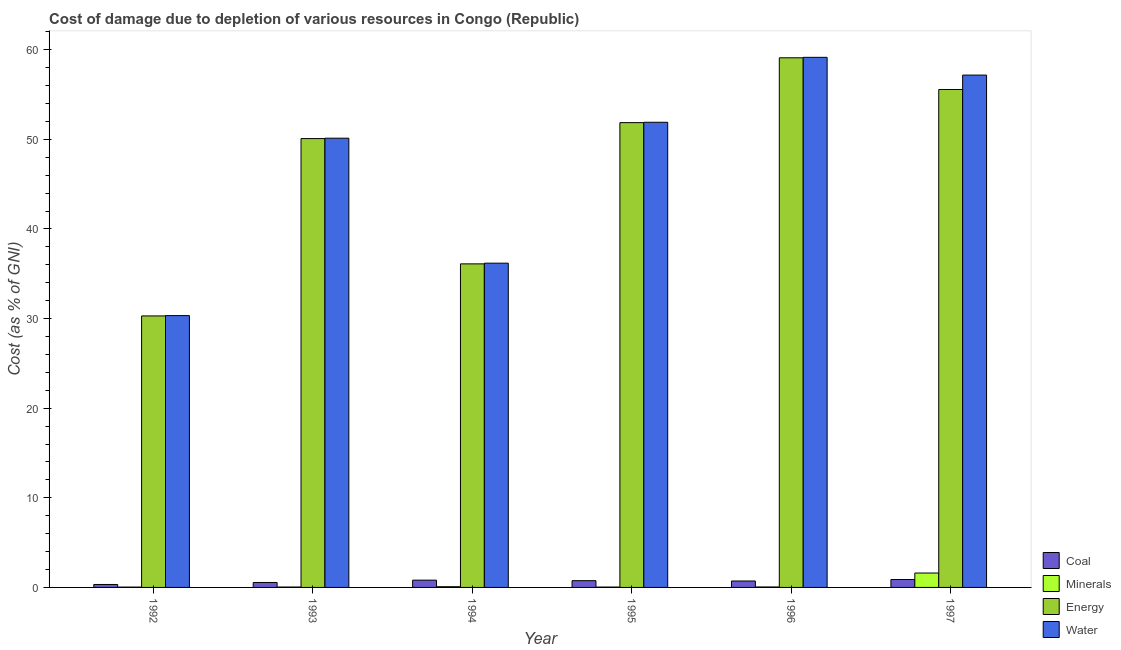How many groups of bars are there?
Provide a short and direct response. 6. How many bars are there on the 6th tick from the left?
Provide a short and direct response. 4. In how many cases, is the number of bars for a given year not equal to the number of legend labels?
Provide a succinct answer. 0. What is the cost of damage due to depletion of coal in 1995?
Keep it short and to the point. 0.75. Across all years, what is the maximum cost of damage due to depletion of minerals?
Provide a succinct answer. 1.61. Across all years, what is the minimum cost of damage due to depletion of energy?
Offer a terse response. 30.3. In which year was the cost of damage due to depletion of coal minimum?
Your answer should be compact. 1992. What is the total cost of damage due to depletion of energy in the graph?
Provide a succinct answer. 283.04. What is the difference between the cost of damage due to depletion of coal in 1992 and that in 1993?
Offer a very short reply. -0.22. What is the difference between the cost of damage due to depletion of water in 1992 and the cost of damage due to depletion of energy in 1993?
Keep it short and to the point. -19.8. What is the average cost of damage due to depletion of energy per year?
Provide a short and direct response. 47.17. What is the ratio of the cost of damage due to depletion of water in 1995 to that in 1996?
Ensure brevity in your answer.  0.88. Is the cost of damage due to depletion of coal in 1996 less than that in 1997?
Provide a succinct answer. Yes. What is the difference between the highest and the second highest cost of damage due to depletion of energy?
Ensure brevity in your answer.  3.54. What is the difference between the highest and the lowest cost of damage due to depletion of energy?
Your answer should be very brief. 28.81. In how many years, is the cost of damage due to depletion of water greater than the average cost of damage due to depletion of water taken over all years?
Your response must be concise. 4. What does the 3rd bar from the left in 1996 represents?
Your answer should be very brief. Energy. What does the 2nd bar from the right in 1994 represents?
Offer a very short reply. Energy. How many bars are there?
Offer a very short reply. 24. Are all the bars in the graph horizontal?
Make the answer very short. No. How many years are there in the graph?
Provide a succinct answer. 6. What is the difference between two consecutive major ticks on the Y-axis?
Ensure brevity in your answer.  10. Does the graph contain grids?
Your response must be concise. No. How are the legend labels stacked?
Your answer should be very brief. Vertical. What is the title of the graph?
Your answer should be compact. Cost of damage due to depletion of various resources in Congo (Republic) . What is the label or title of the X-axis?
Provide a short and direct response. Year. What is the label or title of the Y-axis?
Ensure brevity in your answer.  Cost (as % of GNI). What is the Cost (as % of GNI) in Coal in 1992?
Give a very brief answer. 0.33. What is the Cost (as % of GNI) of Minerals in 1992?
Offer a very short reply. 0.04. What is the Cost (as % of GNI) of Energy in 1992?
Give a very brief answer. 30.3. What is the Cost (as % of GNI) of Water in 1992?
Provide a succinct answer. 30.33. What is the Cost (as % of GNI) of Coal in 1993?
Ensure brevity in your answer.  0.55. What is the Cost (as % of GNI) of Minerals in 1993?
Offer a very short reply. 0.04. What is the Cost (as % of GNI) of Energy in 1993?
Your response must be concise. 50.09. What is the Cost (as % of GNI) in Water in 1993?
Provide a succinct answer. 50.13. What is the Cost (as % of GNI) of Coal in 1994?
Your answer should be compact. 0.81. What is the Cost (as % of GNI) of Minerals in 1994?
Provide a short and direct response. 0.08. What is the Cost (as % of GNI) of Energy in 1994?
Offer a very short reply. 36.11. What is the Cost (as % of GNI) of Water in 1994?
Provide a short and direct response. 36.19. What is the Cost (as % of GNI) of Coal in 1995?
Offer a very short reply. 0.75. What is the Cost (as % of GNI) of Minerals in 1995?
Your answer should be very brief. 0.04. What is the Cost (as % of GNI) in Energy in 1995?
Offer a very short reply. 51.87. What is the Cost (as % of GNI) of Water in 1995?
Give a very brief answer. 51.91. What is the Cost (as % of GNI) in Coal in 1996?
Provide a succinct answer. 0.72. What is the Cost (as % of GNI) in Minerals in 1996?
Keep it short and to the point. 0.05. What is the Cost (as % of GNI) of Energy in 1996?
Keep it short and to the point. 59.11. What is the Cost (as % of GNI) of Water in 1996?
Ensure brevity in your answer.  59.16. What is the Cost (as % of GNI) of Coal in 1997?
Keep it short and to the point. 0.88. What is the Cost (as % of GNI) in Minerals in 1997?
Keep it short and to the point. 1.61. What is the Cost (as % of GNI) in Energy in 1997?
Ensure brevity in your answer.  55.57. What is the Cost (as % of GNI) in Water in 1997?
Ensure brevity in your answer.  57.18. Across all years, what is the maximum Cost (as % of GNI) of Coal?
Offer a terse response. 0.88. Across all years, what is the maximum Cost (as % of GNI) of Minerals?
Your answer should be compact. 1.61. Across all years, what is the maximum Cost (as % of GNI) in Energy?
Offer a terse response. 59.11. Across all years, what is the maximum Cost (as % of GNI) in Water?
Provide a succinct answer. 59.16. Across all years, what is the minimum Cost (as % of GNI) of Coal?
Make the answer very short. 0.33. Across all years, what is the minimum Cost (as % of GNI) of Minerals?
Offer a terse response. 0.04. Across all years, what is the minimum Cost (as % of GNI) of Energy?
Provide a succinct answer. 30.3. Across all years, what is the minimum Cost (as % of GNI) of Water?
Give a very brief answer. 30.33. What is the total Cost (as % of GNI) of Coal in the graph?
Provide a succinct answer. 4.05. What is the total Cost (as % of GNI) of Minerals in the graph?
Make the answer very short. 1.86. What is the total Cost (as % of GNI) in Energy in the graph?
Keep it short and to the point. 283.04. What is the total Cost (as % of GNI) of Water in the graph?
Offer a terse response. 284.89. What is the difference between the Cost (as % of GNI) in Coal in 1992 and that in 1993?
Give a very brief answer. -0.22. What is the difference between the Cost (as % of GNI) of Minerals in 1992 and that in 1993?
Offer a very short reply. -0.01. What is the difference between the Cost (as % of GNI) of Energy in 1992 and that in 1993?
Your answer should be very brief. -19.79. What is the difference between the Cost (as % of GNI) in Water in 1992 and that in 1993?
Provide a short and direct response. -19.8. What is the difference between the Cost (as % of GNI) in Coal in 1992 and that in 1994?
Your response must be concise. -0.48. What is the difference between the Cost (as % of GNI) of Minerals in 1992 and that in 1994?
Keep it short and to the point. -0.04. What is the difference between the Cost (as % of GNI) in Energy in 1992 and that in 1994?
Make the answer very short. -5.81. What is the difference between the Cost (as % of GNI) of Water in 1992 and that in 1994?
Give a very brief answer. -5.85. What is the difference between the Cost (as % of GNI) in Coal in 1992 and that in 1995?
Ensure brevity in your answer.  -0.42. What is the difference between the Cost (as % of GNI) of Minerals in 1992 and that in 1995?
Keep it short and to the point. -0. What is the difference between the Cost (as % of GNI) of Energy in 1992 and that in 1995?
Your answer should be very brief. -21.57. What is the difference between the Cost (as % of GNI) in Water in 1992 and that in 1995?
Make the answer very short. -21.57. What is the difference between the Cost (as % of GNI) in Coal in 1992 and that in 1996?
Your response must be concise. -0.39. What is the difference between the Cost (as % of GNI) of Minerals in 1992 and that in 1996?
Provide a succinct answer. -0.01. What is the difference between the Cost (as % of GNI) of Energy in 1992 and that in 1996?
Your answer should be very brief. -28.81. What is the difference between the Cost (as % of GNI) in Water in 1992 and that in 1996?
Provide a short and direct response. -28.82. What is the difference between the Cost (as % of GNI) of Coal in 1992 and that in 1997?
Keep it short and to the point. -0.55. What is the difference between the Cost (as % of GNI) in Minerals in 1992 and that in 1997?
Provide a short and direct response. -1.57. What is the difference between the Cost (as % of GNI) in Energy in 1992 and that in 1997?
Provide a short and direct response. -25.27. What is the difference between the Cost (as % of GNI) of Water in 1992 and that in 1997?
Your answer should be compact. -26.84. What is the difference between the Cost (as % of GNI) of Coal in 1993 and that in 1994?
Make the answer very short. -0.26. What is the difference between the Cost (as % of GNI) in Minerals in 1993 and that in 1994?
Provide a succinct answer. -0.04. What is the difference between the Cost (as % of GNI) of Energy in 1993 and that in 1994?
Provide a short and direct response. 13.98. What is the difference between the Cost (as % of GNI) of Water in 1993 and that in 1994?
Your answer should be compact. 13.94. What is the difference between the Cost (as % of GNI) in Coal in 1993 and that in 1995?
Ensure brevity in your answer.  -0.2. What is the difference between the Cost (as % of GNI) in Minerals in 1993 and that in 1995?
Your answer should be very brief. 0. What is the difference between the Cost (as % of GNI) in Energy in 1993 and that in 1995?
Provide a short and direct response. -1.78. What is the difference between the Cost (as % of GNI) in Water in 1993 and that in 1995?
Your answer should be compact. -1.78. What is the difference between the Cost (as % of GNI) of Coal in 1993 and that in 1996?
Ensure brevity in your answer.  -0.17. What is the difference between the Cost (as % of GNI) in Minerals in 1993 and that in 1996?
Provide a succinct answer. -0.01. What is the difference between the Cost (as % of GNI) of Energy in 1993 and that in 1996?
Provide a succinct answer. -9.02. What is the difference between the Cost (as % of GNI) in Water in 1993 and that in 1996?
Your answer should be very brief. -9.03. What is the difference between the Cost (as % of GNI) in Coal in 1993 and that in 1997?
Provide a succinct answer. -0.33. What is the difference between the Cost (as % of GNI) in Minerals in 1993 and that in 1997?
Offer a very short reply. -1.56. What is the difference between the Cost (as % of GNI) in Energy in 1993 and that in 1997?
Provide a short and direct response. -5.48. What is the difference between the Cost (as % of GNI) of Water in 1993 and that in 1997?
Make the answer very short. -7.04. What is the difference between the Cost (as % of GNI) in Coal in 1994 and that in 1995?
Provide a short and direct response. 0.06. What is the difference between the Cost (as % of GNI) of Minerals in 1994 and that in 1995?
Ensure brevity in your answer.  0.04. What is the difference between the Cost (as % of GNI) in Energy in 1994 and that in 1995?
Provide a succinct answer. -15.76. What is the difference between the Cost (as % of GNI) of Water in 1994 and that in 1995?
Keep it short and to the point. -15.72. What is the difference between the Cost (as % of GNI) of Coal in 1994 and that in 1996?
Ensure brevity in your answer.  0.09. What is the difference between the Cost (as % of GNI) in Minerals in 1994 and that in 1996?
Offer a very short reply. 0.03. What is the difference between the Cost (as % of GNI) in Energy in 1994 and that in 1996?
Offer a very short reply. -23. What is the difference between the Cost (as % of GNI) in Water in 1994 and that in 1996?
Offer a terse response. -22.97. What is the difference between the Cost (as % of GNI) in Coal in 1994 and that in 1997?
Keep it short and to the point. -0.07. What is the difference between the Cost (as % of GNI) of Minerals in 1994 and that in 1997?
Give a very brief answer. -1.53. What is the difference between the Cost (as % of GNI) in Energy in 1994 and that in 1997?
Offer a terse response. -19.46. What is the difference between the Cost (as % of GNI) of Water in 1994 and that in 1997?
Your answer should be very brief. -20.99. What is the difference between the Cost (as % of GNI) of Coal in 1995 and that in 1996?
Your response must be concise. 0.04. What is the difference between the Cost (as % of GNI) in Minerals in 1995 and that in 1996?
Your answer should be compact. -0.01. What is the difference between the Cost (as % of GNI) of Energy in 1995 and that in 1996?
Give a very brief answer. -7.24. What is the difference between the Cost (as % of GNI) of Water in 1995 and that in 1996?
Give a very brief answer. -7.25. What is the difference between the Cost (as % of GNI) of Coal in 1995 and that in 1997?
Provide a succinct answer. -0.13. What is the difference between the Cost (as % of GNI) of Minerals in 1995 and that in 1997?
Give a very brief answer. -1.57. What is the difference between the Cost (as % of GNI) in Energy in 1995 and that in 1997?
Keep it short and to the point. -3.7. What is the difference between the Cost (as % of GNI) of Water in 1995 and that in 1997?
Offer a terse response. -5.27. What is the difference between the Cost (as % of GNI) in Coal in 1996 and that in 1997?
Your answer should be compact. -0.17. What is the difference between the Cost (as % of GNI) of Minerals in 1996 and that in 1997?
Offer a very short reply. -1.56. What is the difference between the Cost (as % of GNI) in Energy in 1996 and that in 1997?
Provide a short and direct response. 3.54. What is the difference between the Cost (as % of GNI) of Water in 1996 and that in 1997?
Your answer should be compact. 1.98. What is the difference between the Cost (as % of GNI) of Coal in 1992 and the Cost (as % of GNI) of Minerals in 1993?
Keep it short and to the point. 0.29. What is the difference between the Cost (as % of GNI) of Coal in 1992 and the Cost (as % of GNI) of Energy in 1993?
Give a very brief answer. -49.76. What is the difference between the Cost (as % of GNI) in Coal in 1992 and the Cost (as % of GNI) in Water in 1993?
Your answer should be very brief. -49.8. What is the difference between the Cost (as % of GNI) of Minerals in 1992 and the Cost (as % of GNI) of Energy in 1993?
Make the answer very short. -50.05. What is the difference between the Cost (as % of GNI) in Minerals in 1992 and the Cost (as % of GNI) in Water in 1993?
Keep it short and to the point. -50.1. What is the difference between the Cost (as % of GNI) in Energy in 1992 and the Cost (as % of GNI) in Water in 1993?
Give a very brief answer. -19.83. What is the difference between the Cost (as % of GNI) in Coal in 1992 and the Cost (as % of GNI) in Minerals in 1994?
Make the answer very short. 0.25. What is the difference between the Cost (as % of GNI) of Coal in 1992 and the Cost (as % of GNI) of Energy in 1994?
Provide a short and direct response. -35.78. What is the difference between the Cost (as % of GNI) of Coal in 1992 and the Cost (as % of GNI) of Water in 1994?
Provide a succinct answer. -35.86. What is the difference between the Cost (as % of GNI) in Minerals in 1992 and the Cost (as % of GNI) in Energy in 1994?
Keep it short and to the point. -36.07. What is the difference between the Cost (as % of GNI) in Minerals in 1992 and the Cost (as % of GNI) in Water in 1994?
Provide a succinct answer. -36.15. What is the difference between the Cost (as % of GNI) in Energy in 1992 and the Cost (as % of GNI) in Water in 1994?
Offer a terse response. -5.89. What is the difference between the Cost (as % of GNI) of Coal in 1992 and the Cost (as % of GNI) of Minerals in 1995?
Ensure brevity in your answer.  0.29. What is the difference between the Cost (as % of GNI) in Coal in 1992 and the Cost (as % of GNI) in Energy in 1995?
Offer a very short reply. -51.54. What is the difference between the Cost (as % of GNI) in Coal in 1992 and the Cost (as % of GNI) in Water in 1995?
Your response must be concise. -51.58. What is the difference between the Cost (as % of GNI) in Minerals in 1992 and the Cost (as % of GNI) in Energy in 1995?
Keep it short and to the point. -51.83. What is the difference between the Cost (as % of GNI) in Minerals in 1992 and the Cost (as % of GNI) in Water in 1995?
Make the answer very short. -51.87. What is the difference between the Cost (as % of GNI) in Energy in 1992 and the Cost (as % of GNI) in Water in 1995?
Ensure brevity in your answer.  -21.61. What is the difference between the Cost (as % of GNI) in Coal in 1992 and the Cost (as % of GNI) in Minerals in 1996?
Keep it short and to the point. 0.28. What is the difference between the Cost (as % of GNI) in Coal in 1992 and the Cost (as % of GNI) in Energy in 1996?
Your answer should be compact. -58.78. What is the difference between the Cost (as % of GNI) in Coal in 1992 and the Cost (as % of GNI) in Water in 1996?
Keep it short and to the point. -58.83. What is the difference between the Cost (as % of GNI) in Minerals in 1992 and the Cost (as % of GNI) in Energy in 1996?
Your answer should be compact. -59.07. What is the difference between the Cost (as % of GNI) in Minerals in 1992 and the Cost (as % of GNI) in Water in 1996?
Your answer should be compact. -59.12. What is the difference between the Cost (as % of GNI) of Energy in 1992 and the Cost (as % of GNI) of Water in 1996?
Make the answer very short. -28.86. What is the difference between the Cost (as % of GNI) of Coal in 1992 and the Cost (as % of GNI) of Minerals in 1997?
Offer a terse response. -1.28. What is the difference between the Cost (as % of GNI) of Coal in 1992 and the Cost (as % of GNI) of Energy in 1997?
Your answer should be compact. -55.24. What is the difference between the Cost (as % of GNI) of Coal in 1992 and the Cost (as % of GNI) of Water in 1997?
Your answer should be compact. -56.85. What is the difference between the Cost (as % of GNI) in Minerals in 1992 and the Cost (as % of GNI) in Energy in 1997?
Offer a terse response. -55.53. What is the difference between the Cost (as % of GNI) in Minerals in 1992 and the Cost (as % of GNI) in Water in 1997?
Make the answer very short. -57.14. What is the difference between the Cost (as % of GNI) of Energy in 1992 and the Cost (as % of GNI) of Water in 1997?
Keep it short and to the point. -26.88. What is the difference between the Cost (as % of GNI) of Coal in 1993 and the Cost (as % of GNI) of Minerals in 1994?
Offer a terse response. 0.47. What is the difference between the Cost (as % of GNI) of Coal in 1993 and the Cost (as % of GNI) of Energy in 1994?
Provide a succinct answer. -35.55. What is the difference between the Cost (as % of GNI) in Coal in 1993 and the Cost (as % of GNI) in Water in 1994?
Ensure brevity in your answer.  -35.63. What is the difference between the Cost (as % of GNI) of Minerals in 1993 and the Cost (as % of GNI) of Energy in 1994?
Give a very brief answer. -36.06. What is the difference between the Cost (as % of GNI) of Minerals in 1993 and the Cost (as % of GNI) of Water in 1994?
Your answer should be compact. -36.14. What is the difference between the Cost (as % of GNI) of Energy in 1993 and the Cost (as % of GNI) of Water in 1994?
Your answer should be very brief. 13.9. What is the difference between the Cost (as % of GNI) in Coal in 1993 and the Cost (as % of GNI) in Minerals in 1995?
Provide a succinct answer. 0.51. What is the difference between the Cost (as % of GNI) of Coal in 1993 and the Cost (as % of GNI) of Energy in 1995?
Your answer should be very brief. -51.32. What is the difference between the Cost (as % of GNI) of Coal in 1993 and the Cost (as % of GNI) of Water in 1995?
Give a very brief answer. -51.36. What is the difference between the Cost (as % of GNI) in Minerals in 1993 and the Cost (as % of GNI) in Energy in 1995?
Make the answer very short. -51.83. What is the difference between the Cost (as % of GNI) of Minerals in 1993 and the Cost (as % of GNI) of Water in 1995?
Make the answer very short. -51.87. What is the difference between the Cost (as % of GNI) of Energy in 1993 and the Cost (as % of GNI) of Water in 1995?
Offer a very short reply. -1.82. What is the difference between the Cost (as % of GNI) in Coal in 1993 and the Cost (as % of GNI) in Minerals in 1996?
Ensure brevity in your answer.  0.5. What is the difference between the Cost (as % of GNI) of Coal in 1993 and the Cost (as % of GNI) of Energy in 1996?
Provide a succinct answer. -58.55. What is the difference between the Cost (as % of GNI) in Coal in 1993 and the Cost (as % of GNI) in Water in 1996?
Keep it short and to the point. -58.6. What is the difference between the Cost (as % of GNI) in Minerals in 1993 and the Cost (as % of GNI) in Energy in 1996?
Offer a very short reply. -59.06. What is the difference between the Cost (as % of GNI) of Minerals in 1993 and the Cost (as % of GNI) of Water in 1996?
Offer a very short reply. -59.11. What is the difference between the Cost (as % of GNI) in Energy in 1993 and the Cost (as % of GNI) in Water in 1996?
Provide a short and direct response. -9.07. What is the difference between the Cost (as % of GNI) in Coal in 1993 and the Cost (as % of GNI) in Minerals in 1997?
Give a very brief answer. -1.05. What is the difference between the Cost (as % of GNI) of Coal in 1993 and the Cost (as % of GNI) of Energy in 1997?
Make the answer very short. -55.01. What is the difference between the Cost (as % of GNI) in Coal in 1993 and the Cost (as % of GNI) in Water in 1997?
Offer a very short reply. -56.62. What is the difference between the Cost (as % of GNI) in Minerals in 1993 and the Cost (as % of GNI) in Energy in 1997?
Provide a succinct answer. -55.52. What is the difference between the Cost (as % of GNI) in Minerals in 1993 and the Cost (as % of GNI) in Water in 1997?
Keep it short and to the point. -57.13. What is the difference between the Cost (as % of GNI) in Energy in 1993 and the Cost (as % of GNI) in Water in 1997?
Provide a short and direct response. -7.09. What is the difference between the Cost (as % of GNI) of Coal in 1994 and the Cost (as % of GNI) of Minerals in 1995?
Give a very brief answer. 0.77. What is the difference between the Cost (as % of GNI) in Coal in 1994 and the Cost (as % of GNI) in Energy in 1995?
Ensure brevity in your answer.  -51.06. What is the difference between the Cost (as % of GNI) in Coal in 1994 and the Cost (as % of GNI) in Water in 1995?
Provide a short and direct response. -51.1. What is the difference between the Cost (as % of GNI) in Minerals in 1994 and the Cost (as % of GNI) in Energy in 1995?
Keep it short and to the point. -51.79. What is the difference between the Cost (as % of GNI) of Minerals in 1994 and the Cost (as % of GNI) of Water in 1995?
Your response must be concise. -51.83. What is the difference between the Cost (as % of GNI) in Energy in 1994 and the Cost (as % of GNI) in Water in 1995?
Provide a short and direct response. -15.8. What is the difference between the Cost (as % of GNI) of Coal in 1994 and the Cost (as % of GNI) of Minerals in 1996?
Your response must be concise. 0.76. What is the difference between the Cost (as % of GNI) in Coal in 1994 and the Cost (as % of GNI) in Energy in 1996?
Provide a succinct answer. -58.29. What is the difference between the Cost (as % of GNI) in Coal in 1994 and the Cost (as % of GNI) in Water in 1996?
Offer a very short reply. -58.34. What is the difference between the Cost (as % of GNI) of Minerals in 1994 and the Cost (as % of GNI) of Energy in 1996?
Give a very brief answer. -59.03. What is the difference between the Cost (as % of GNI) of Minerals in 1994 and the Cost (as % of GNI) of Water in 1996?
Provide a succinct answer. -59.08. What is the difference between the Cost (as % of GNI) in Energy in 1994 and the Cost (as % of GNI) in Water in 1996?
Your answer should be compact. -23.05. What is the difference between the Cost (as % of GNI) of Coal in 1994 and the Cost (as % of GNI) of Minerals in 1997?
Offer a very short reply. -0.8. What is the difference between the Cost (as % of GNI) in Coal in 1994 and the Cost (as % of GNI) in Energy in 1997?
Offer a very short reply. -54.76. What is the difference between the Cost (as % of GNI) in Coal in 1994 and the Cost (as % of GNI) in Water in 1997?
Make the answer very short. -56.36. What is the difference between the Cost (as % of GNI) in Minerals in 1994 and the Cost (as % of GNI) in Energy in 1997?
Make the answer very short. -55.49. What is the difference between the Cost (as % of GNI) of Minerals in 1994 and the Cost (as % of GNI) of Water in 1997?
Give a very brief answer. -57.1. What is the difference between the Cost (as % of GNI) of Energy in 1994 and the Cost (as % of GNI) of Water in 1997?
Give a very brief answer. -21.07. What is the difference between the Cost (as % of GNI) in Coal in 1995 and the Cost (as % of GNI) in Minerals in 1996?
Give a very brief answer. 0.7. What is the difference between the Cost (as % of GNI) of Coal in 1995 and the Cost (as % of GNI) of Energy in 1996?
Provide a short and direct response. -58.35. What is the difference between the Cost (as % of GNI) of Coal in 1995 and the Cost (as % of GNI) of Water in 1996?
Make the answer very short. -58.4. What is the difference between the Cost (as % of GNI) in Minerals in 1995 and the Cost (as % of GNI) in Energy in 1996?
Give a very brief answer. -59.07. What is the difference between the Cost (as % of GNI) in Minerals in 1995 and the Cost (as % of GNI) in Water in 1996?
Your answer should be very brief. -59.12. What is the difference between the Cost (as % of GNI) of Energy in 1995 and the Cost (as % of GNI) of Water in 1996?
Provide a succinct answer. -7.29. What is the difference between the Cost (as % of GNI) of Coal in 1995 and the Cost (as % of GNI) of Minerals in 1997?
Give a very brief answer. -0.85. What is the difference between the Cost (as % of GNI) of Coal in 1995 and the Cost (as % of GNI) of Energy in 1997?
Provide a short and direct response. -54.81. What is the difference between the Cost (as % of GNI) of Coal in 1995 and the Cost (as % of GNI) of Water in 1997?
Your answer should be very brief. -56.42. What is the difference between the Cost (as % of GNI) of Minerals in 1995 and the Cost (as % of GNI) of Energy in 1997?
Offer a very short reply. -55.53. What is the difference between the Cost (as % of GNI) of Minerals in 1995 and the Cost (as % of GNI) of Water in 1997?
Keep it short and to the point. -57.14. What is the difference between the Cost (as % of GNI) of Energy in 1995 and the Cost (as % of GNI) of Water in 1997?
Your answer should be very brief. -5.31. What is the difference between the Cost (as % of GNI) in Coal in 1996 and the Cost (as % of GNI) in Minerals in 1997?
Offer a terse response. -0.89. What is the difference between the Cost (as % of GNI) in Coal in 1996 and the Cost (as % of GNI) in Energy in 1997?
Offer a terse response. -54.85. What is the difference between the Cost (as % of GNI) of Coal in 1996 and the Cost (as % of GNI) of Water in 1997?
Keep it short and to the point. -56.46. What is the difference between the Cost (as % of GNI) in Minerals in 1996 and the Cost (as % of GNI) in Energy in 1997?
Provide a succinct answer. -55.52. What is the difference between the Cost (as % of GNI) of Minerals in 1996 and the Cost (as % of GNI) of Water in 1997?
Offer a terse response. -57.12. What is the difference between the Cost (as % of GNI) of Energy in 1996 and the Cost (as % of GNI) of Water in 1997?
Give a very brief answer. 1.93. What is the average Cost (as % of GNI) in Coal per year?
Your response must be concise. 0.67. What is the average Cost (as % of GNI) in Minerals per year?
Your answer should be very brief. 0.31. What is the average Cost (as % of GNI) of Energy per year?
Your answer should be compact. 47.17. What is the average Cost (as % of GNI) of Water per year?
Give a very brief answer. 47.48. In the year 1992, what is the difference between the Cost (as % of GNI) in Coal and Cost (as % of GNI) in Minerals?
Provide a succinct answer. 0.29. In the year 1992, what is the difference between the Cost (as % of GNI) of Coal and Cost (as % of GNI) of Energy?
Offer a very short reply. -29.97. In the year 1992, what is the difference between the Cost (as % of GNI) in Coal and Cost (as % of GNI) in Water?
Your answer should be compact. -30.01. In the year 1992, what is the difference between the Cost (as % of GNI) of Minerals and Cost (as % of GNI) of Energy?
Give a very brief answer. -30.26. In the year 1992, what is the difference between the Cost (as % of GNI) of Minerals and Cost (as % of GNI) of Water?
Give a very brief answer. -30.3. In the year 1992, what is the difference between the Cost (as % of GNI) in Energy and Cost (as % of GNI) in Water?
Provide a short and direct response. -0.04. In the year 1993, what is the difference between the Cost (as % of GNI) of Coal and Cost (as % of GNI) of Minerals?
Make the answer very short. 0.51. In the year 1993, what is the difference between the Cost (as % of GNI) in Coal and Cost (as % of GNI) in Energy?
Provide a succinct answer. -49.54. In the year 1993, what is the difference between the Cost (as % of GNI) of Coal and Cost (as % of GNI) of Water?
Provide a short and direct response. -49.58. In the year 1993, what is the difference between the Cost (as % of GNI) in Minerals and Cost (as % of GNI) in Energy?
Ensure brevity in your answer.  -50.05. In the year 1993, what is the difference between the Cost (as % of GNI) in Minerals and Cost (as % of GNI) in Water?
Keep it short and to the point. -50.09. In the year 1993, what is the difference between the Cost (as % of GNI) in Energy and Cost (as % of GNI) in Water?
Your answer should be compact. -0.04. In the year 1994, what is the difference between the Cost (as % of GNI) of Coal and Cost (as % of GNI) of Minerals?
Ensure brevity in your answer.  0.73. In the year 1994, what is the difference between the Cost (as % of GNI) in Coal and Cost (as % of GNI) in Energy?
Offer a very short reply. -35.3. In the year 1994, what is the difference between the Cost (as % of GNI) in Coal and Cost (as % of GNI) in Water?
Offer a terse response. -35.37. In the year 1994, what is the difference between the Cost (as % of GNI) of Minerals and Cost (as % of GNI) of Energy?
Make the answer very short. -36.03. In the year 1994, what is the difference between the Cost (as % of GNI) of Minerals and Cost (as % of GNI) of Water?
Keep it short and to the point. -36.11. In the year 1994, what is the difference between the Cost (as % of GNI) in Energy and Cost (as % of GNI) in Water?
Offer a very short reply. -0.08. In the year 1995, what is the difference between the Cost (as % of GNI) of Coal and Cost (as % of GNI) of Minerals?
Make the answer very short. 0.71. In the year 1995, what is the difference between the Cost (as % of GNI) in Coal and Cost (as % of GNI) in Energy?
Provide a succinct answer. -51.12. In the year 1995, what is the difference between the Cost (as % of GNI) in Coal and Cost (as % of GNI) in Water?
Offer a terse response. -51.16. In the year 1995, what is the difference between the Cost (as % of GNI) of Minerals and Cost (as % of GNI) of Energy?
Your response must be concise. -51.83. In the year 1995, what is the difference between the Cost (as % of GNI) in Minerals and Cost (as % of GNI) in Water?
Your answer should be compact. -51.87. In the year 1995, what is the difference between the Cost (as % of GNI) in Energy and Cost (as % of GNI) in Water?
Offer a terse response. -0.04. In the year 1996, what is the difference between the Cost (as % of GNI) of Coal and Cost (as % of GNI) of Minerals?
Offer a terse response. 0.67. In the year 1996, what is the difference between the Cost (as % of GNI) of Coal and Cost (as % of GNI) of Energy?
Provide a succinct answer. -58.39. In the year 1996, what is the difference between the Cost (as % of GNI) of Coal and Cost (as % of GNI) of Water?
Keep it short and to the point. -58.44. In the year 1996, what is the difference between the Cost (as % of GNI) in Minerals and Cost (as % of GNI) in Energy?
Provide a short and direct response. -59.05. In the year 1996, what is the difference between the Cost (as % of GNI) in Minerals and Cost (as % of GNI) in Water?
Your answer should be very brief. -59.11. In the year 1996, what is the difference between the Cost (as % of GNI) in Energy and Cost (as % of GNI) in Water?
Ensure brevity in your answer.  -0.05. In the year 1997, what is the difference between the Cost (as % of GNI) in Coal and Cost (as % of GNI) in Minerals?
Provide a short and direct response. -0.72. In the year 1997, what is the difference between the Cost (as % of GNI) in Coal and Cost (as % of GNI) in Energy?
Your answer should be very brief. -54.68. In the year 1997, what is the difference between the Cost (as % of GNI) of Coal and Cost (as % of GNI) of Water?
Keep it short and to the point. -56.29. In the year 1997, what is the difference between the Cost (as % of GNI) in Minerals and Cost (as % of GNI) in Energy?
Your answer should be compact. -53.96. In the year 1997, what is the difference between the Cost (as % of GNI) in Minerals and Cost (as % of GNI) in Water?
Provide a short and direct response. -55.57. In the year 1997, what is the difference between the Cost (as % of GNI) of Energy and Cost (as % of GNI) of Water?
Your response must be concise. -1.61. What is the ratio of the Cost (as % of GNI) in Coal in 1992 to that in 1993?
Your answer should be very brief. 0.59. What is the ratio of the Cost (as % of GNI) of Minerals in 1992 to that in 1993?
Keep it short and to the point. 0.84. What is the ratio of the Cost (as % of GNI) in Energy in 1992 to that in 1993?
Give a very brief answer. 0.6. What is the ratio of the Cost (as % of GNI) of Water in 1992 to that in 1993?
Offer a terse response. 0.61. What is the ratio of the Cost (as % of GNI) in Coal in 1992 to that in 1994?
Your answer should be very brief. 0.41. What is the ratio of the Cost (as % of GNI) in Minerals in 1992 to that in 1994?
Your response must be concise. 0.46. What is the ratio of the Cost (as % of GNI) of Energy in 1992 to that in 1994?
Offer a very short reply. 0.84. What is the ratio of the Cost (as % of GNI) of Water in 1992 to that in 1994?
Provide a succinct answer. 0.84. What is the ratio of the Cost (as % of GNI) of Coal in 1992 to that in 1995?
Keep it short and to the point. 0.44. What is the ratio of the Cost (as % of GNI) of Minerals in 1992 to that in 1995?
Your response must be concise. 0.91. What is the ratio of the Cost (as % of GNI) of Energy in 1992 to that in 1995?
Your answer should be compact. 0.58. What is the ratio of the Cost (as % of GNI) in Water in 1992 to that in 1995?
Keep it short and to the point. 0.58. What is the ratio of the Cost (as % of GNI) of Coal in 1992 to that in 1996?
Offer a very short reply. 0.46. What is the ratio of the Cost (as % of GNI) in Energy in 1992 to that in 1996?
Offer a terse response. 0.51. What is the ratio of the Cost (as % of GNI) in Water in 1992 to that in 1996?
Ensure brevity in your answer.  0.51. What is the ratio of the Cost (as % of GNI) of Coal in 1992 to that in 1997?
Ensure brevity in your answer.  0.37. What is the ratio of the Cost (as % of GNI) of Minerals in 1992 to that in 1997?
Make the answer very short. 0.02. What is the ratio of the Cost (as % of GNI) of Energy in 1992 to that in 1997?
Make the answer very short. 0.55. What is the ratio of the Cost (as % of GNI) in Water in 1992 to that in 1997?
Make the answer very short. 0.53. What is the ratio of the Cost (as % of GNI) in Coal in 1993 to that in 1994?
Provide a succinct answer. 0.68. What is the ratio of the Cost (as % of GNI) of Minerals in 1993 to that in 1994?
Offer a terse response. 0.54. What is the ratio of the Cost (as % of GNI) of Energy in 1993 to that in 1994?
Give a very brief answer. 1.39. What is the ratio of the Cost (as % of GNI) in Water in 1993 to that in 1994?
Make the answer very short. 1.39. What is the ratio of the Cost (as % of GNI) of Coal in 1993 to that in 1995?
Your answer should be very brief. 0.73. What is the ratio of the Cost (as % of GNI) of Minerals in 1993 to that in 1995?
Make the answer very short. 1.08. What is the ratio of the Cost (as % of GNI) of Energy in 1993 to that in 1995?
Your response must be concise. 0.97. What is the ratio of the Cost (as % of GNI) in Water in 1993 to that in 1995?
Give a very brief answer. 0.97. What is the ratio of the Cost (as % of GNI) of Coal in 1993 to that in 1996?
Ensure brevity in your answer.  0.77. What is the ratio of the Cost (as % of GNI) in Minerals in 1993 to that in 1996?
Make the answer very short. 0.85. What is the ratio of the Cost (as % of GNI) of Energy in 1993 to that in 1996?
Make the answer very short. 0.85. What is the ratio of the Cost (as % of GNI) of Water in 1993 to that in 1996?
Ensure brevity in your answer.  0.85. What is the ratio of the Cost (as % of GNI) in Coal in 1993 to that in 1997?
Give a very brief answer. 0.63. What is the ratio of the Cost (as % of GNI) in Minerals in 1993 to that in 1997?
Provide a short and direct response. 0.03. What is the ratio of the Cost (as % of GNI) of Energy in 1993 to that in 1997?
Offer a terse response. 0.9. What is the ratio of the Cost (as % of GNI) in Water in 1993 to that in 1997?
Offer a terse response. 0.88. What is the ratio of the Cost (as % of GNI) of Coal in 1994 to that in 1995?
Your answer should be compact. 1.08. What is the ratio of the Cost (as % of GNI) in Minerals in 1994 to that in 1995?
Ensure brevity in your answer.  2. What is the ratio of the Cost (as % of GNI) of Energy in 1994 to that in 1995?
Your response must be concise. 0.7. What is the ratio of the Cost (as % of GNI) in Water in 1994 to that in 1995?
Offer a very short reply. 0.7. What is the ratio of the Cost (as % of GNI) in Coal in 1994 to that in 1996?
Your answer should be very brief. 1.13. What is the ratio of the Cost (as % of GNI) in Minerals in 1994 to that in 1996?
Your response must be concise. 1.56. What is the ratio of the Cost (as % of GNI) of Energy in 1994 to that in 1996?
Keep it short and to the point. 0.61. What is the ratio of the Cost (as % of GNI) in Water in 1994 to that in 1996?
Keep it short and to the point. 0.61. What is the ratio of the Cost (as % of GNI) in Coal in 1994 to that in 1997?
Your answer should be very brief. 0.92. What is the ratio of the Cost (as % of GNI) in Minerals in 1994 to that in 1997?
Offer a terse response. 0.05. What is the ratio of the Cost (as % of GNI) in Energy in 1994 to that in 1997?
Give a very brief answer. 0.65. What is the ratio of the Cost (as % of GNI) of Water in 1994 to that in 1997?
Ensure brevity in your answer.  0.63. What is the ratio of the Cost (as % of GNI) in Coal in 1995 to that in 1996?
Provide a short and direct response. 1.05. What is the ratio of the Cost (as % of GNI) in Minerals in 1995 to that in 1996?
Your answer should be compact. 0.78. What is the ratio of the Cost (as % of GNI) in Energy in 1995 to that in 1996?
Your answer should be compact. 0.88. What is the ratio of the Cost (as % of GNI) in Water in 1995 to that in 1996?
Offer a very short reply. 0.88. What is the ratio of the Cost (as % of GNI) of Coal in 1995 to that in 1997?
Offer a very short reply. 0.85. What is the ratio of the Cost (as % of GNI) of Minerals in 1995 to that in 1997?
Offer a very short reply. 0.02. What is the ratio of the Cost (as % of GNI) in Energy in 1995 to that in 1997?
Ensure brevity in your answer.  0.93. What is the ratio of the Cost (as % of GNI) in Water in 1995 to that in 1997?
Offer a terse response. 0.91. What is the ratio of the Cost (as % of GNI) in Coal in 1996 to that in 1997?
Give a very brief answer. 0.81. What is the ratio of the Cost (as % of GNI) in Minerals in 1996 to that in 1997?
Your answer should be compact. 0.03. What is the ratio of the Cost (as % of GNI) in Energy in 1996 to that in 1997?
Make the answer very short. 1.06. What is the ratio of the Cost (as % of GNI) of Water in 1996 to that in 1997?
Keep it short and to the point. 1.03. What is the difference between the highest and the second highest Cost (as % of GNI) in Coal?
Ensure brevity in your answer.  0.07. What is the difference between the highest and the second highest Cost (as % of GNI) of Minerals?
Keep it short and to the point. 1.53. What is the difference between the highest and the second highest Cost (as % of GNI) of Energy?
Provide a short and direct response. 3.54. What is the difference between the highest and the second highest Cost (as % of GNI) in Water?
Make the answer very short. 1.98. What is the difference between the highest and the lowest Cost (as % of GNI) of Coal?
Give a very brief answer. 0.55. What is the difference between the highest and the lowest Cost (as % of GNI) of Minerals?
Your answer should be very brief. 1.57. What is the difference between the highest and the lowest Cost (as % of GNI) of Energy?
Your response must be concise. 28.81. What is the difference between the highest and the lowest Cost (as % of GNI) of Water?
Keep it short and to the point. 28.82. 